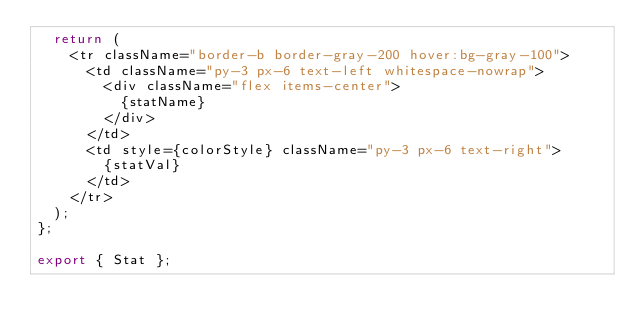<code> <loc_0><loc_0><loc_500><loc_500><_TypeScript_>  return (
    <tr className="border-b border-gray-200 hover:bg-gray-100">
      <td className="py-3 px-6 text-left whitespace-nowrap">
        <div className="flex items-center">
          {statName}
        </div>
      </td>
      <td style={colorStyle} className="py-3 px-6 text-right">
        {statVal}
      </td>
    </tr>
  );
};

export { Stat };
</code> 